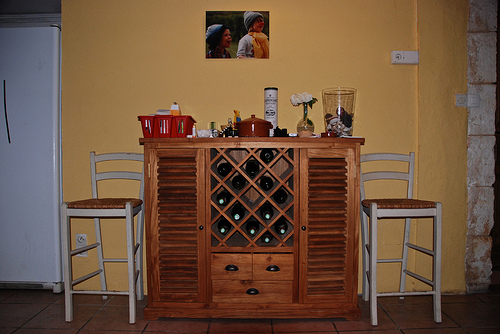<image>
Is there a bottle on the floor? No. The bottle is not positioned on the floor. They may be near each other, but the bottle is not supported by or resting on top of the floor. Where is the cupboard in relation to the chair? Is it to the right of the chair? Yes. From this viewpoint, the cupboard is positioned to the right side relative to the chair. Is the wine in the cabinet? Yes. The wine is contained within or inside the cabinet, showing a containment relationship. 